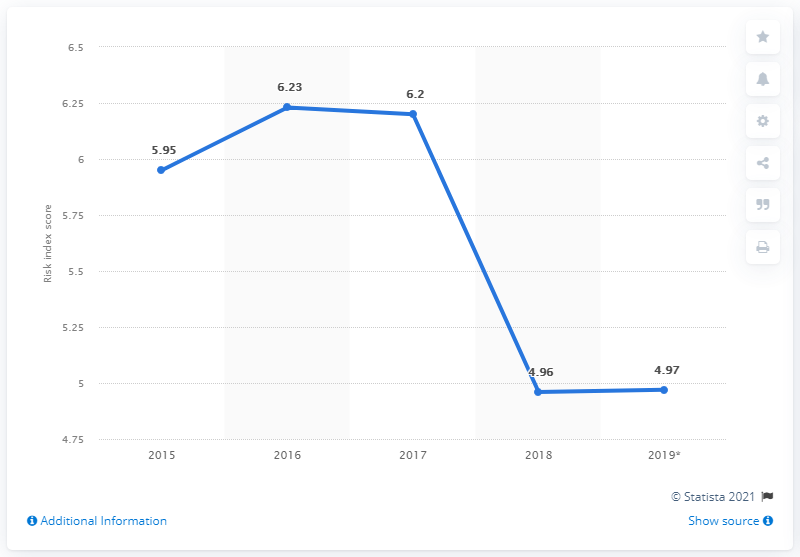Draw attention to some important aspects in this diagram. Brazil's index score in 2019 was 4.97, indicating a moderate level of corruption in the country. Based on the risk index score, the year with the lowest score was 2018. In 2017, the risk value was greater than in 2015. 